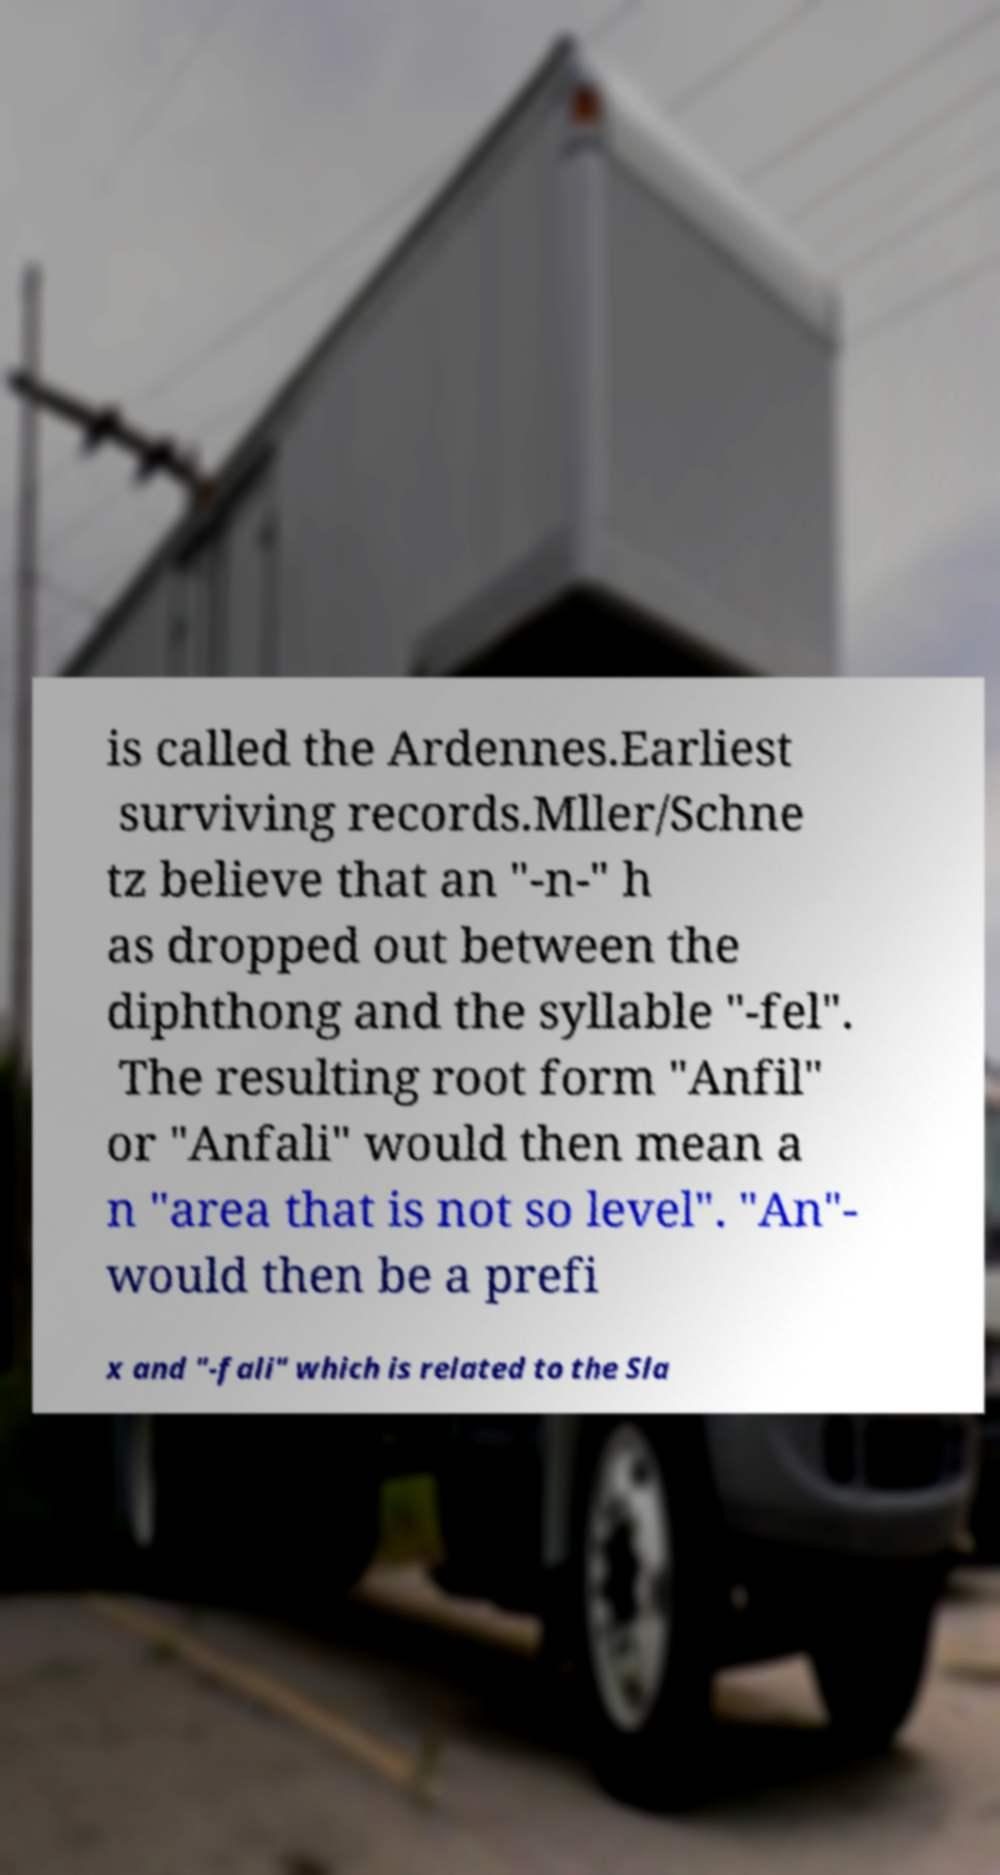There's text embedded in this image that I need extracted. Can you transcribe it verbatim? is called the Ardennes.Earliest surviving records.Mller/Schne tz believe that an "-n-" h as dropped out between the diphthong and the syllable "-fel". The resulting root form "Anfil" or "Anfali" would then mean a n "area that is not so level". "An"- would then be a prefi x and "-fali" which is related to the Sla 